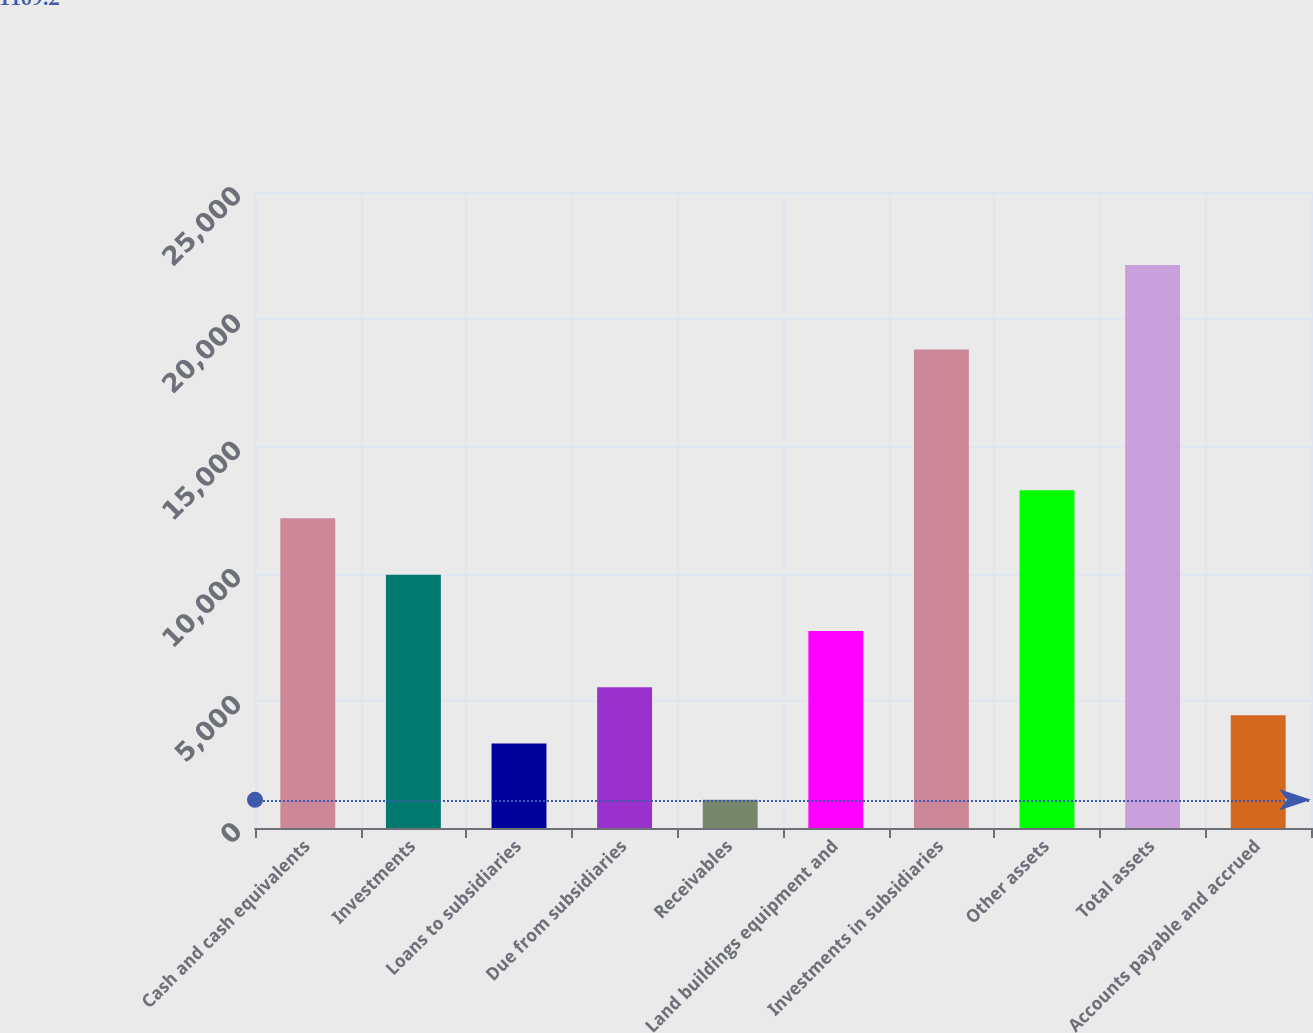Convert chart to OTSL. <chart><loc_0><loc_0><loc_500><loc_500><bar_chart><fcel>Cash and cash equivalents<fcel>Investments<fcel>Loans to subsidiaries<fcel>Due from subsidiaries<fcel>Receivables<fcel>Land buildings equipment and<fcel>Investments in subsidiaries<fcel>Other assets<fcel>Total assets<fcel>Accounts payable and accrued<nl><fcel>12171.2<fcel>9958.8<fcel>3321.6<fcel>5534<fcel>1109.2<fcel>7746.4<fcel>18808.4<fcel>13277.4<fcel>22127<fcel>4427.8<nl></chart> 